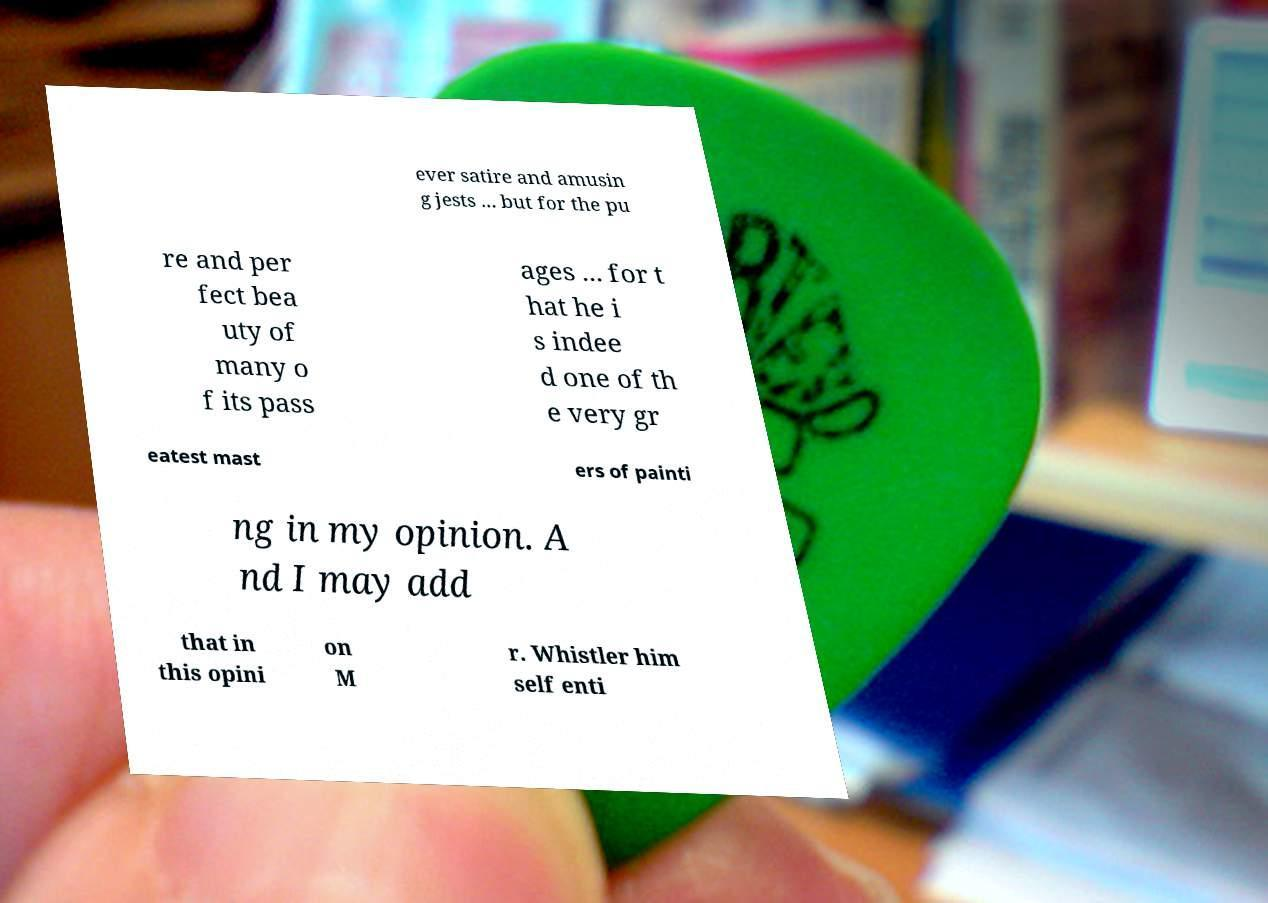What messages or text are displayed in this image? I need them in a readable, typed format. ever satire and amusin g jests ... but for the pu re and per fect bea uty of many o f its pass ages ... for t hat he i s indee d one of th e very gr eatest mast ers of painti ng in my opinion. A nd I may add that in this opini on M r. Whistler him self enti 